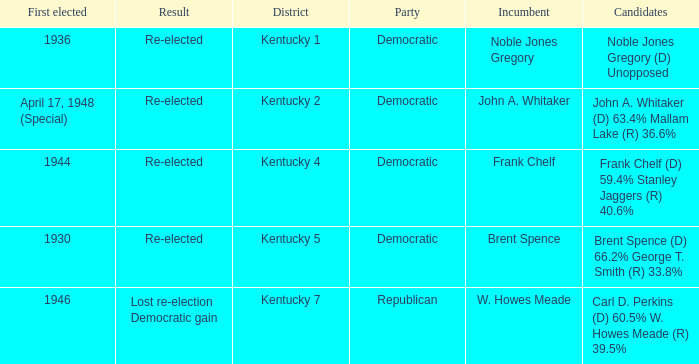Who were the candidates in the Kentucky 4 voting district? Frank Chelf (D) 59.4% Stanley Jaggers (R) 40.6%. 